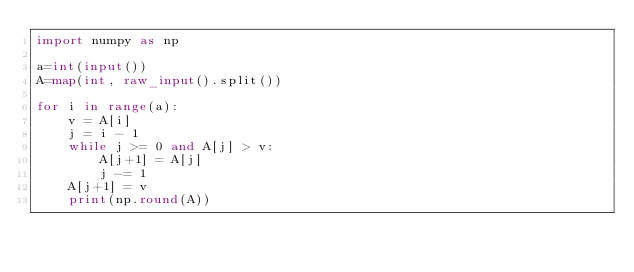Convert code to text. <code><loc_0><loc_0><loc_500><loc_500><_Python_>import numpy as np

a=int(input())
A=map(int, raw_input().split())

for i in range(a):
    v = A[i]
    j = i - 1
    while j >= 0 and A[j] > v:
        A[j+1] = A[j]
        j -= 1
    A[j+1] = v
    print(np.round(A))
</code> 